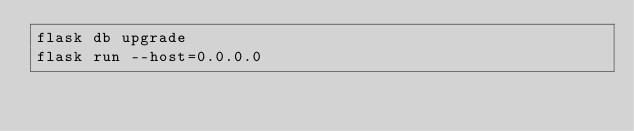<code> <loc_0><loc_0><loc_500><loc_500><_Bash_>flask db upgrade
flask run --host=0.0.0.0</code> 